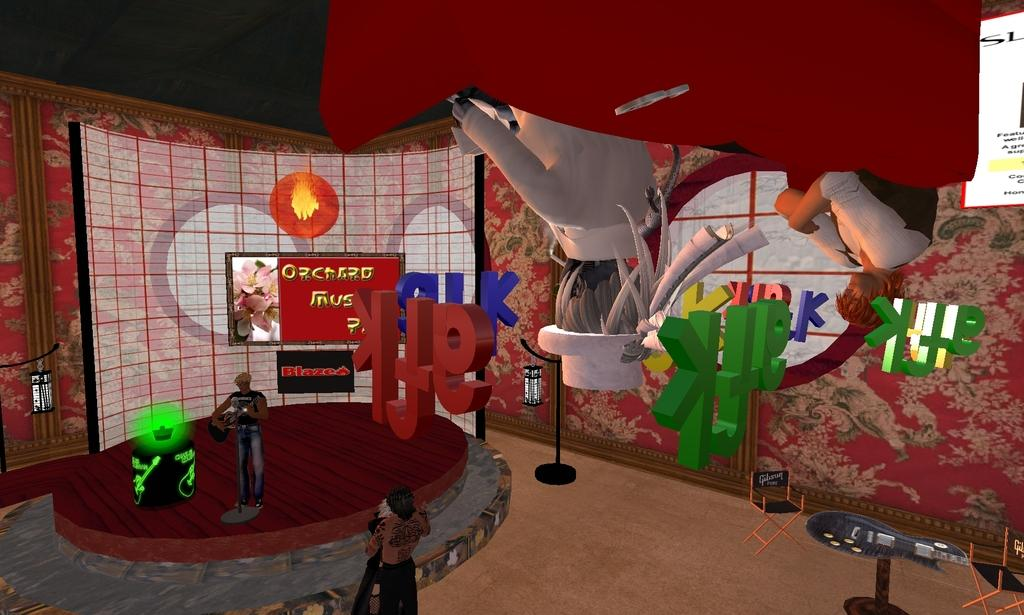What types of characters are present in the image? There are animated objects and people in the image. Can you describe the background of the image? The background of the image includes a red wall. How many kittens are sitting on the shoulders of the people in the image? There are no kittens present in the image. What position do the animated objects hold in relation to the people in the image? The provided facts do not specify the position or relationship between the animated objects and the people in the image. 